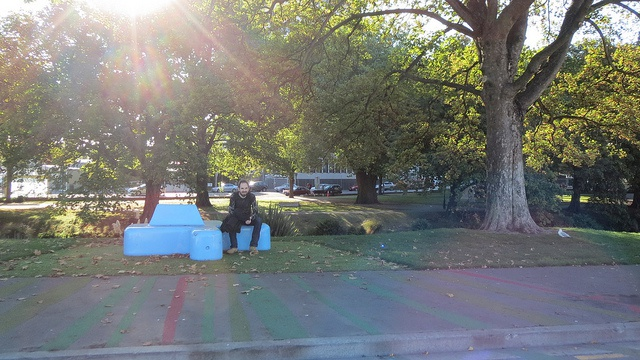Describe the objects in this image and their specific colors. I can see bench in white, lightblue, and gray tones, people in white, black, gray, and darkgray tones, car in white, black, and gray tones, car in white, gray, and darkgray tones, and car in white, darkgray, gray, and lightgray tones in this image. 